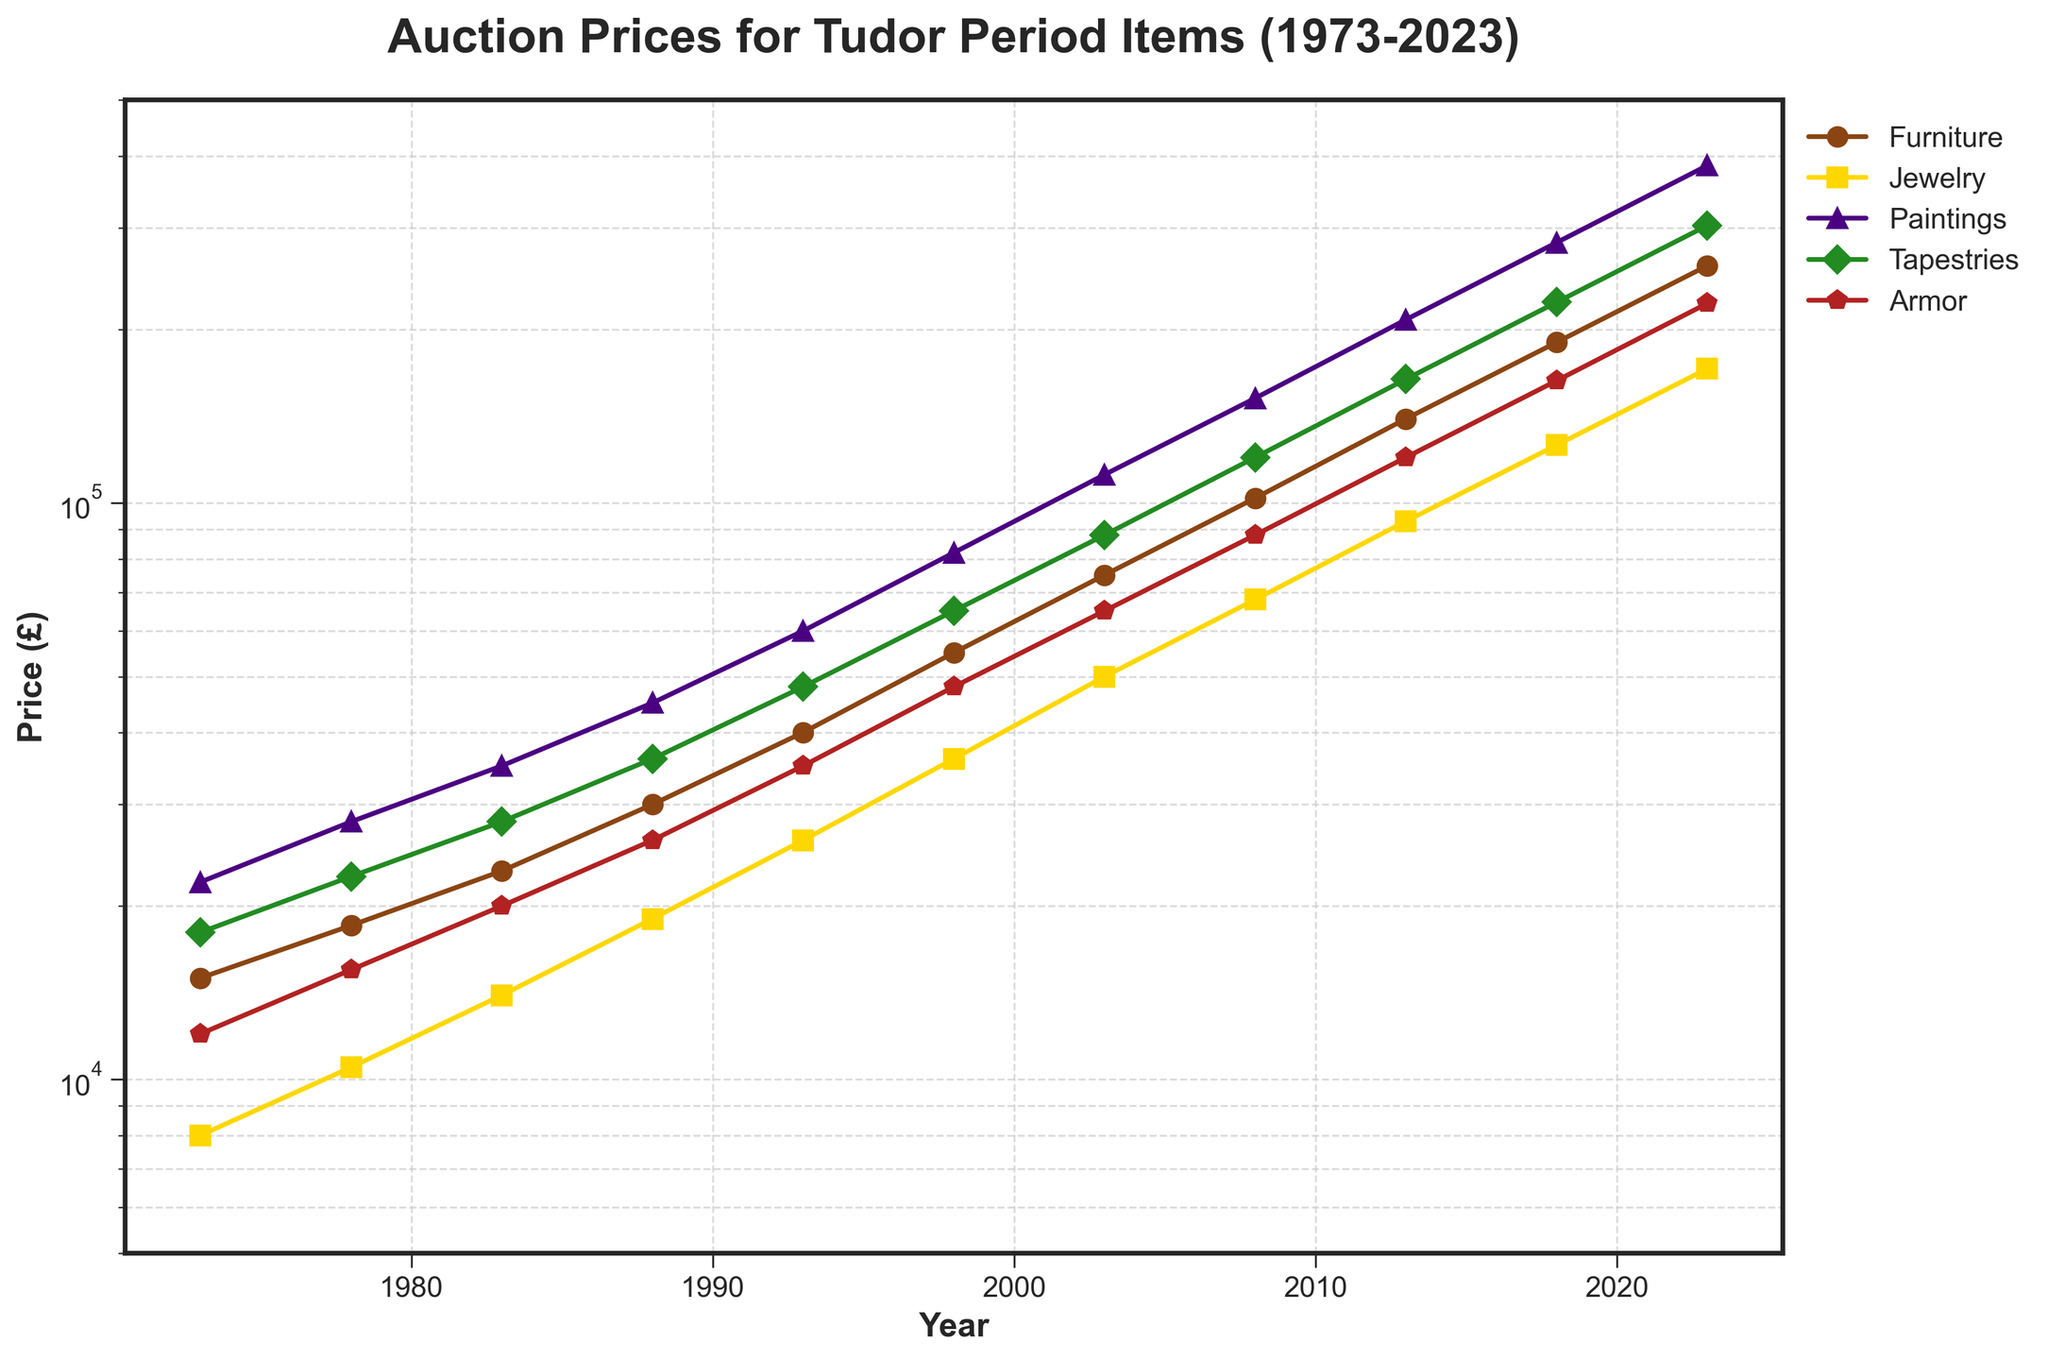How much did the price of Tudor period Furniture increase from 1973 to 2023? Find the price of Furniture in 1973 (15000) and in 2023 (258000), then subtract the 1973 price from the 2023 price: 258000 - 15000 = 243000
Answer: 243000 Which category had the highest auction price in 2023? Compare the price values of all categories in 2023. The prices are Furniture (258000), Jewelry (171000), Paintings (385000), Tapestries (303000), and Armor (222000). The highest value is 385000 for Paintings
Answer: Paintings Between which years did Tudor period Jewelry see the largest increase in auction price? Calculate the price increase for each interval: 1973-1978 (10500-8000=2500), 1978-1983 (14000-10500=3500), 1983-1988 (19000-14000=5000), 1988-1993 (26000-19000=7000), 1993-1998 (36000-26000=10000), 1998-2003 (50000-36000=14000), 2003-2008 (68000-50000=18000), 2008-2013 (93000-68000=25000), 2013-2018 (126000-93000=33000), and 2018-2023 (171000-126000=45000). The largest increase is from 2018 to 2023
Answer: Between 2018 and 2023 Which item category showed the most consistent rise in auction prices from 1973 to 2023? Evaluate the overall trend for each category. All categories are increasing, but the consistency in the slope is to be checked. Jewelry consistently rises without any falling gaps, indicating a steady increase
Answer: Jewelry How did the auction price of Tudor period Tapestries change between 1998 and 2008? Determine the price of Tapestries in 1998 (65000) and in 2008 (120000) and find the difference: 120000 - 65000 = 55000
Answer: Increased by 55000 What is the average auction price of Tudor period Paintings over the five years shown (1973, 1978, 1983, 1988, 1993)? Sum the prices of Paintings for those years (22000 + 28000 + 35000 + 45000 + 60000) and divide by the number of years (5): (22000 + 28000 + 35000 + 45000 + 60000) / 5 = 38000
Answer: 38000 Between which years did Tudor period Armor experience its steepest price increase? Calculate the increase for each period as done before, focusing on Armor. Comparing intervals, the steepest increase appears to be between 2018 (163000) and 2023 (222000): 222000 - 163000 = 59000
Answer: Between 2018 and 2023 Which color represents the Jewelry category in the plot? Identify the color and marker used for Jewelry which corresponds to the line in gold color on the plot
Answer: Gold Did the auction prices for any category decline or stabilize at any point over 50 years? Check all the categories' progress year by year. No declines or stabilization periods apparent as all lines show a continuous increase
Answer: No What is the price difference between Furniture and Armor in 2008? Compare the prices of Furniture (102000) and Armor (88000) in 2008, then find the difference: 102000 - 88000 = 14000
Answer: 14000 